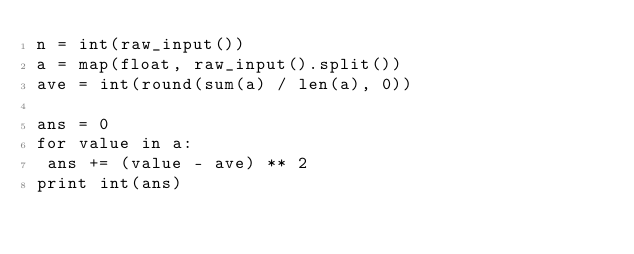<code> <loc_0><loc_0><loc_500><loc_500><_Python_>n = int(raw_input())
a = map(float, raw_input().split())
ave = int(round(sum(a) / len(a), 0))

ans = 0
for value in a:
 ans += (value - ave) ** 2
print int(ans)</code> 